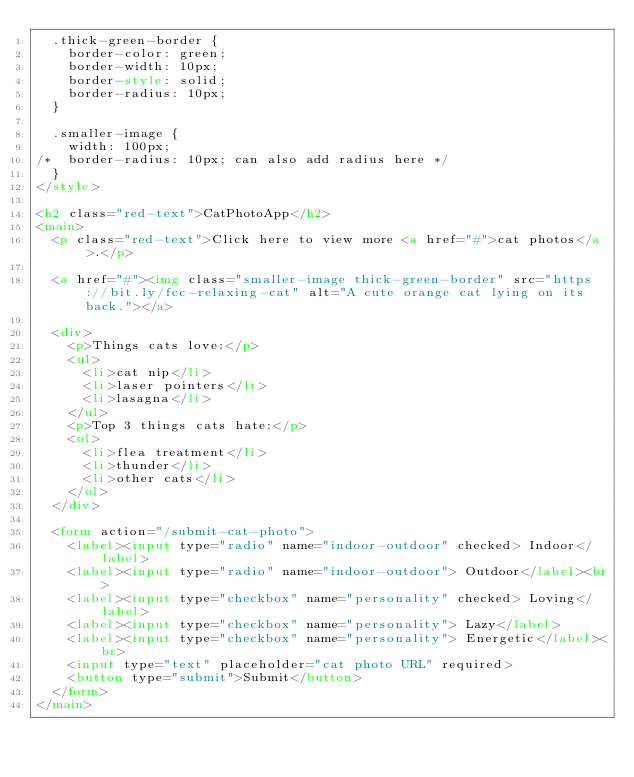Convert code to text. <code><loc_0><loc_0><loc_500><loc_500><_HTML_>  .thick-green-border {
    border-color: green;
    border-width: 10px;
    border-style: solid;
    border-radius: 10px;    
  }

  .smaller-image {
    width: 100px;
/*  border-radius: 10px; can also add radius here */
  }
</style>

<h2 class="red-text">CatPhotoApp</h2>
<main>
  <p class="red-text">Click here to view more <a href="#">cat photos</a>.</p>

  <a href="#"><img class="smaller-image thick-green-border" src="https://bit.ly/fcc-relaxing-cat" alt="A cute orange cat lying on its back."></a>

  <div>
    <p>Things cats love:</p>
    <ul>
      <li>cat nip</li>
      <li>laser pointers</li>
      <li>lasagna</li>
    </ul>
    <p>Top 3 things cats hate:</p>
    <ol>
      <li>flea treatment</li>
      <li>thunder</li>
      <li>other cats</li>
    </ol>
  </div>

  <form action="/submit-cat-photo">
    <label><input type="radio" name="indoor-outdoor" checked> Indoor</label>
    <label><input type="radio" name="indoor-outdoor"> Outdoor</label><br>
    <label><input type="checkbox" name="personality" checked> Loving</label>
    <label><input type="checkbox" name="personality"> Lazy</label>
    <label><input type="checkbox" name="personality"> Energetic</label><br>
    <input type="text" placeholder="cat photo URL" required>
    <button type="submit">Submit</button>
  </form>
</main>
</code> 